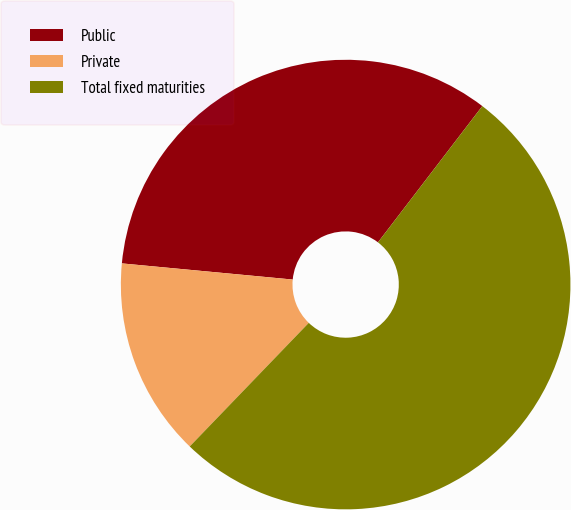Convert chart to OTSL. <chart><loc_0><loc_0><loc_500><loc_500><pie_chart><fcel>Public<fcel>Private<fcel>Total fixed maturities<nl><fcel>33.9%<fcel>14.3%<fcel>51.8%<nl></chart> 